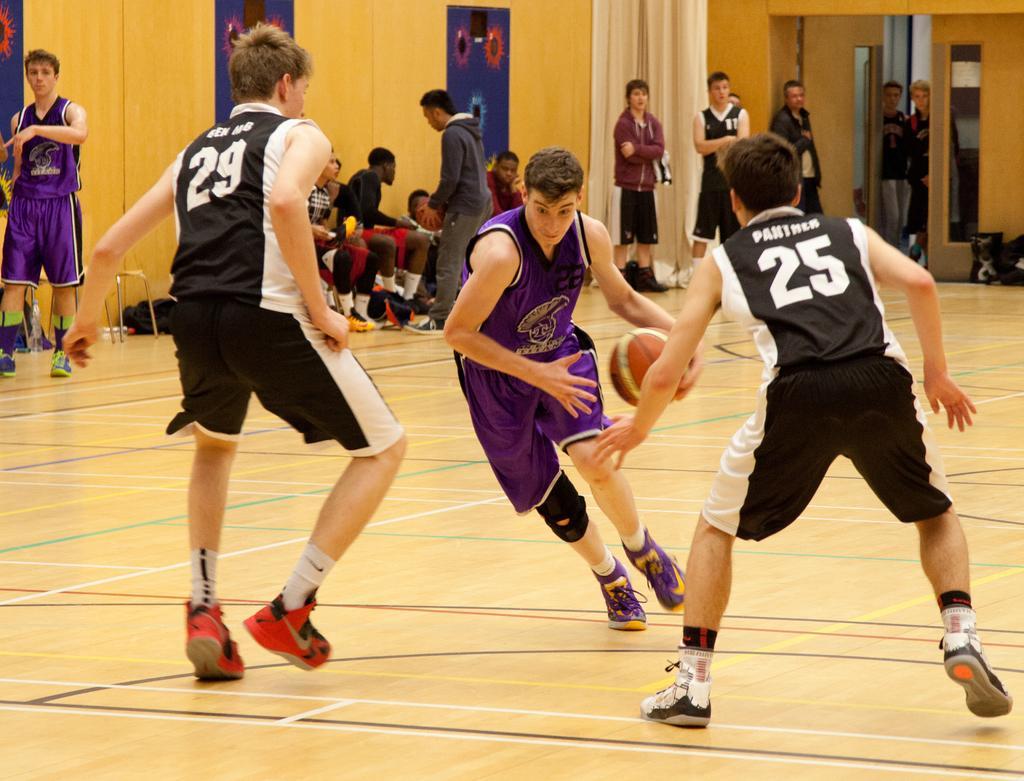How would you summarize this image in a sentence or two? In the image there are few boys in black jersey and few boys in purple jersey playing basketball on the basketball field inside a hall, in the back there are few persons standing and sitting staring at the game. 